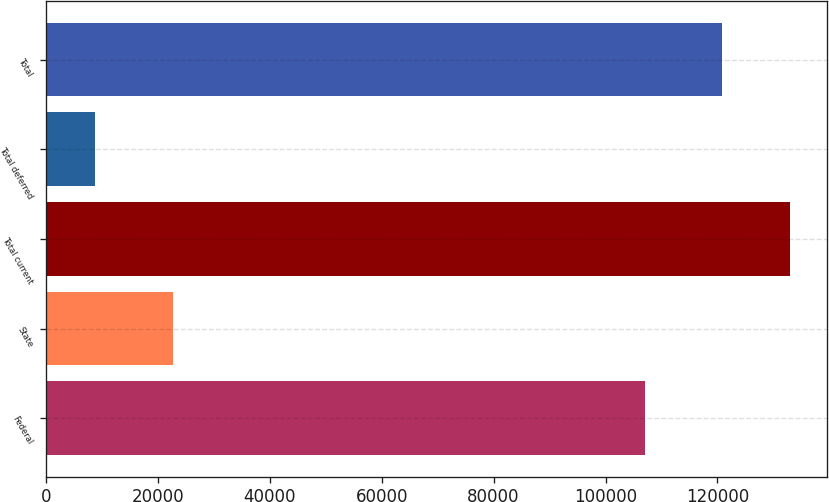Convert chart. <chart><loc_0><loc_0><loc_500><loc_500><bar_chart><fcel>Federal<fcel>State<fcel>Total current<fcel>Total deferred<fcel>Total<nl><fcel>107083<fcel>22646<fcel>132972<fcel>8845<fcel>120884<nl></chart> 